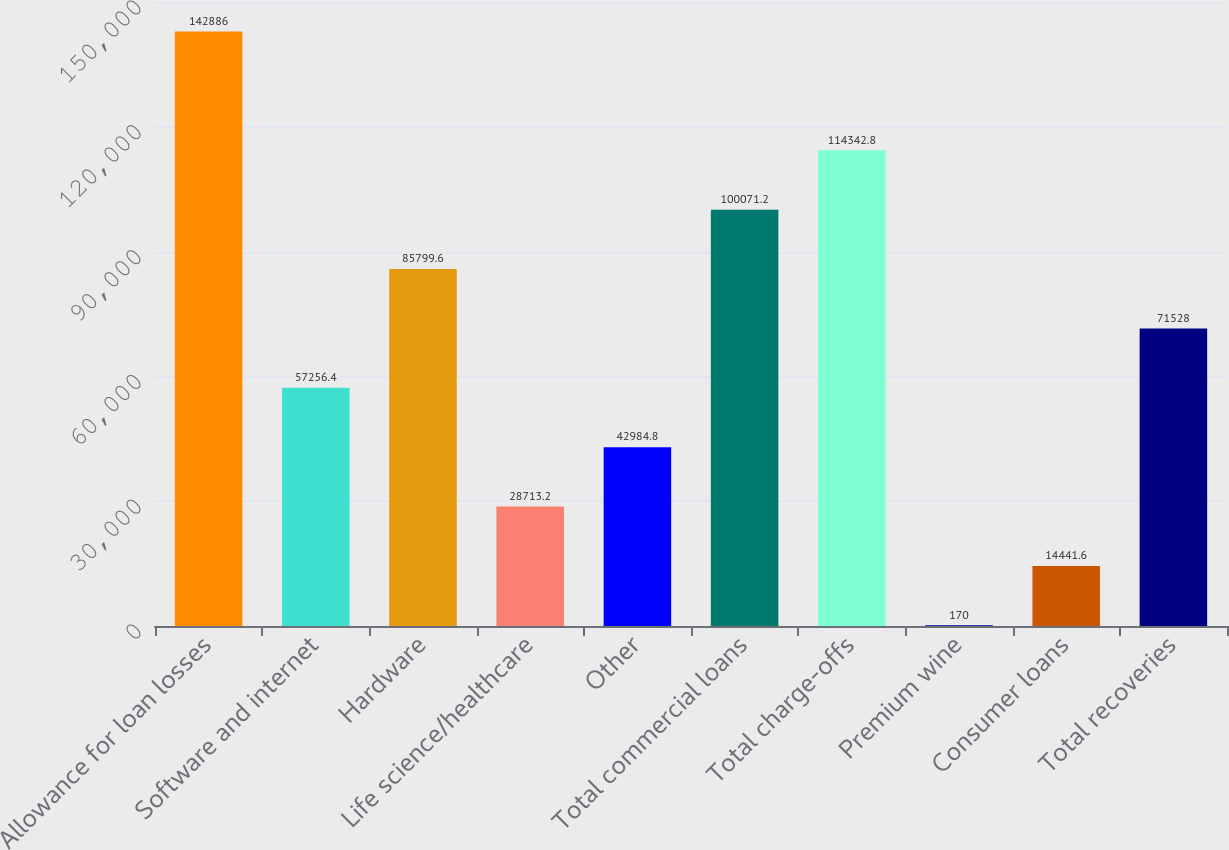<chart> <loc_0><loc_0><loc_500><loc_500><bar_chart><fcel>Allowance for loan losses<fcel>Software and internet<fcel>Hardware<fcel>Life science/healthcare<fcel>Other<fcel>Total commercial loans<fcel>Total charge-offs<fcel>Premium wine<fcel>Consumer loans<fcel>Total recoveries<nl><fcel>142886<fcel>57256.4<fcel>85799.6<fcel>28713.2<fcel>42984.8<fcel>100071<fcel>114343<fcel>170<fcel>14441.6<fcel>71528<nl></chart> 